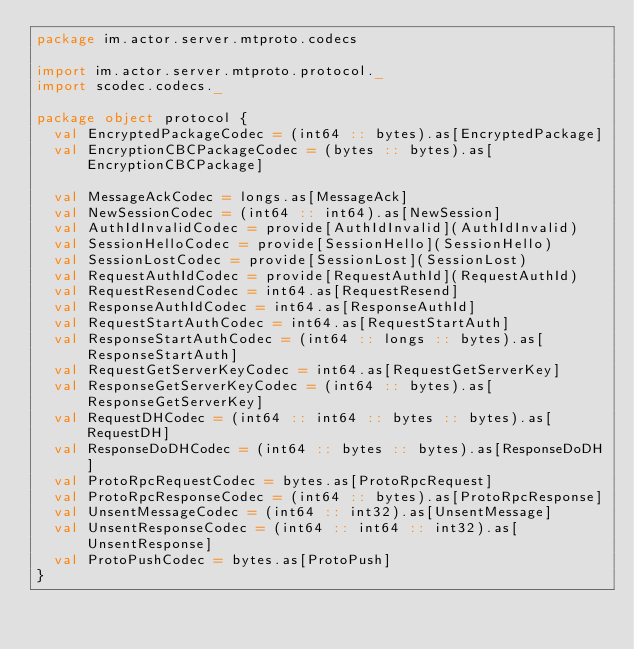Convert code to text. <code><loc_0><loc_0><loc_500><loc_500><_Scala_>package im.actor.server.mtproto.codecs

import im.actor.server.mtproto.protocol._
import scodec.codecs._

package object protocol {
  val EncryptedPackageCodec = (int64 :: bytes).as[EncryptedPackage]
  val EncryptionCBCPackageCodec = (bytes :: bytes).as[EncryptionCBCPackage]

  val MessageAckCodec = longs.as[MessageAck]
  val NewSessionCodec = (int64 :: int64).as[NewSession]
  val AuthIdInvalidCodec = provide[AuthIdInvalid](AuthIdInvalid)
  val SessionHelloCodec = provide[SessionHello](SessionHello)
  val SessionLostCodec = provide[SessionLost](SessionLost)
  val RequestAuthIdCodec = provide[RequestAuthId](RequestAuthId)
  val RequestResendCodec = int64.as[RequestResend]
  val ResponseAuthIdCodec = int64.as[ResponseAuthId]
  val RequestStartAuthCodec = int64.as[RequestStartAuth]
  val ResponseStartAuthCodec = (int64 :: longs :: bytes).as[ResponseStartAuth]
  val RequestGetServerKeyCodec = int64.as[RequestGetServerKey]
  val ResponseGetServerKeyCodec = (int64 :: bytes).as[ResponseGetServerKey]
  val RequestDHCodec = (int64 :: int64 :: bytes :: bytes).as[RequestDH]
  val ResponseDoDHCodec = (int64 :: bytes :: bytes).as[ResponseDoDH]
  val ProtoRpcRequestCodec = bytes.as[ProtoRpcRequest]
  val ProtoRpcResponseCodec = (int64 :: bytes).as[ProtoRpcResponse]
  val UnsentMessageCodec = (int64 :: int32).as[UnsentMessage]
  val UnsentResponseCodec = (int64 :: int64 :: int32).as[UnsentResponse]
  val ProtoPushCodec = bytes.as[ProtoPush]
}
</code> 